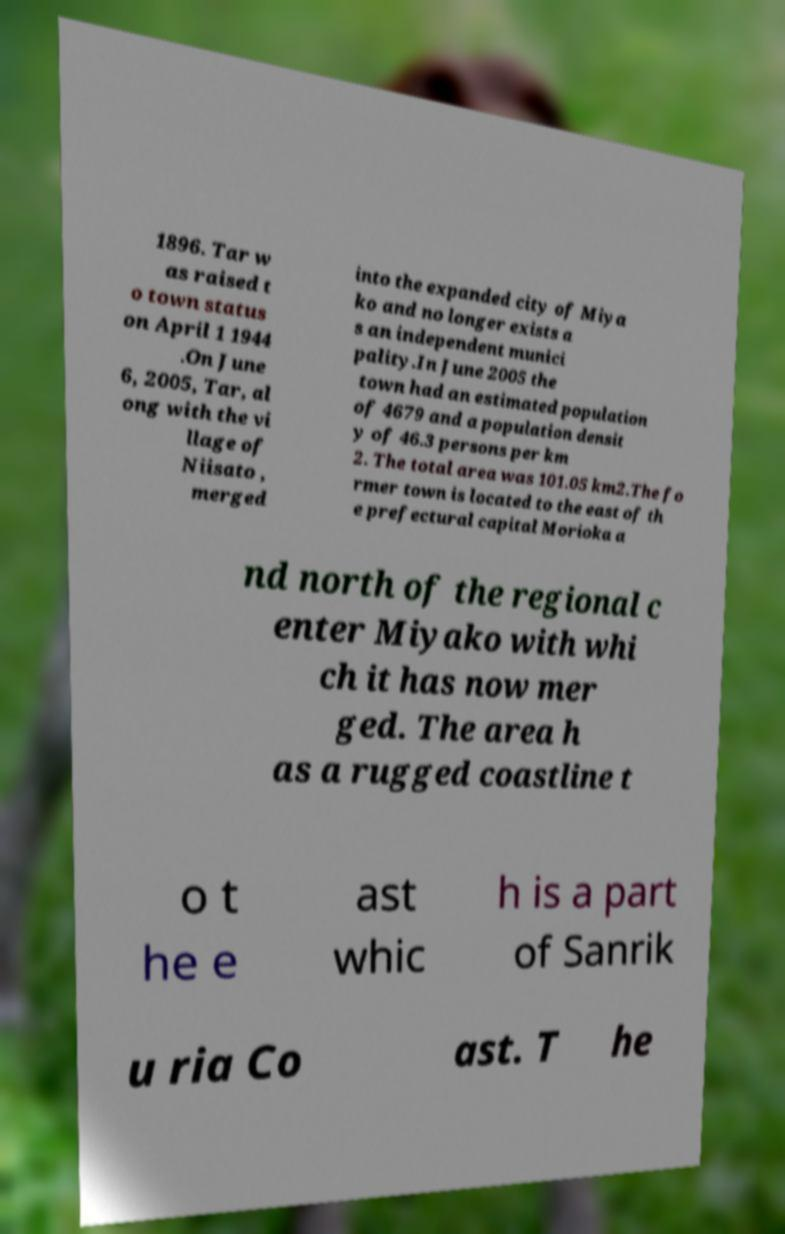Can you read and provide the text displayed in the image?This photo seems to have some interesting text. Can you extract and type it out for me? 1896. Tar w as raised t o town status on April 1 1944 .On June 6, 2005, Tar, al ong with the vi llage of Niisato , merged into the expanded city of Miya ko and no longer exists a s an independent munici pality.In June 2005 the town had an estimated population of 4679 and a population densit y of 46.3 persons per km 2. The total area was 101.05 km2.The fo rmer town is located to the east of th e prefectural capital Morioka a nd north of the regional c enter Miyako with whi ch it has now mer ged. The area h as a rugged coastline t o t he e ast whic h is a part of Sanrik u ria Co ast. T he 